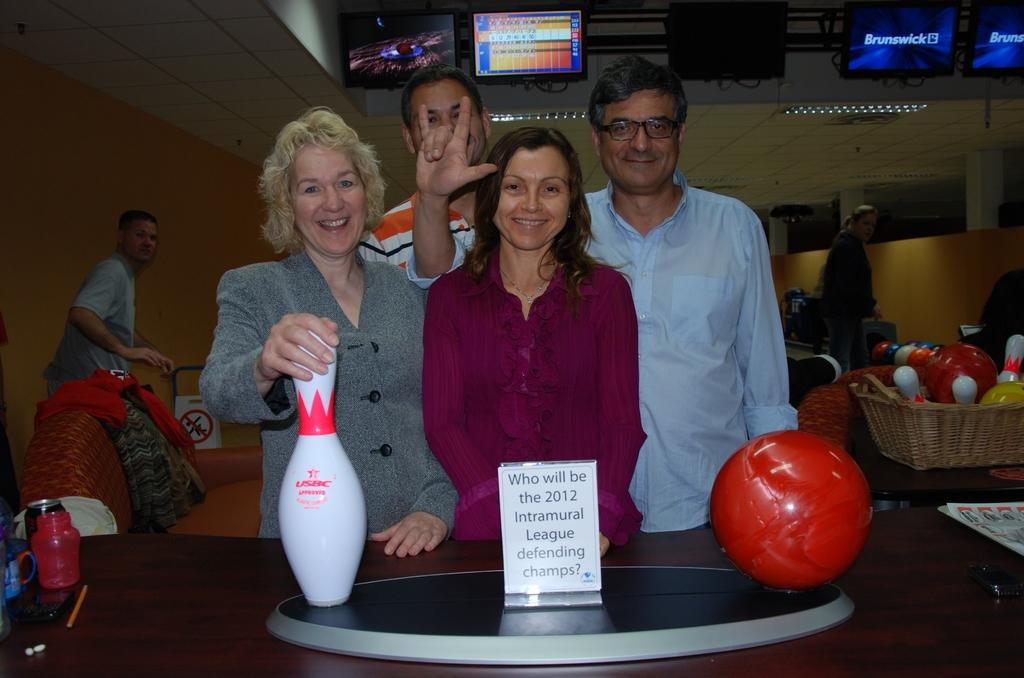What is happening in the image? There are persons standing in the image. What can be seen at the top of the image? There are television screens at the top of the image. What object is visible in the image that is typically used for playing games or sports? There is a ball visible in the image. What type of object can be seen on the table in the image that contains written information? There is a paper with text on it placed on a table. What type of shop can be seen in the background of the image? There is no shop visible in the image. What is the wax used for in the image? There is no wax present in the image. 